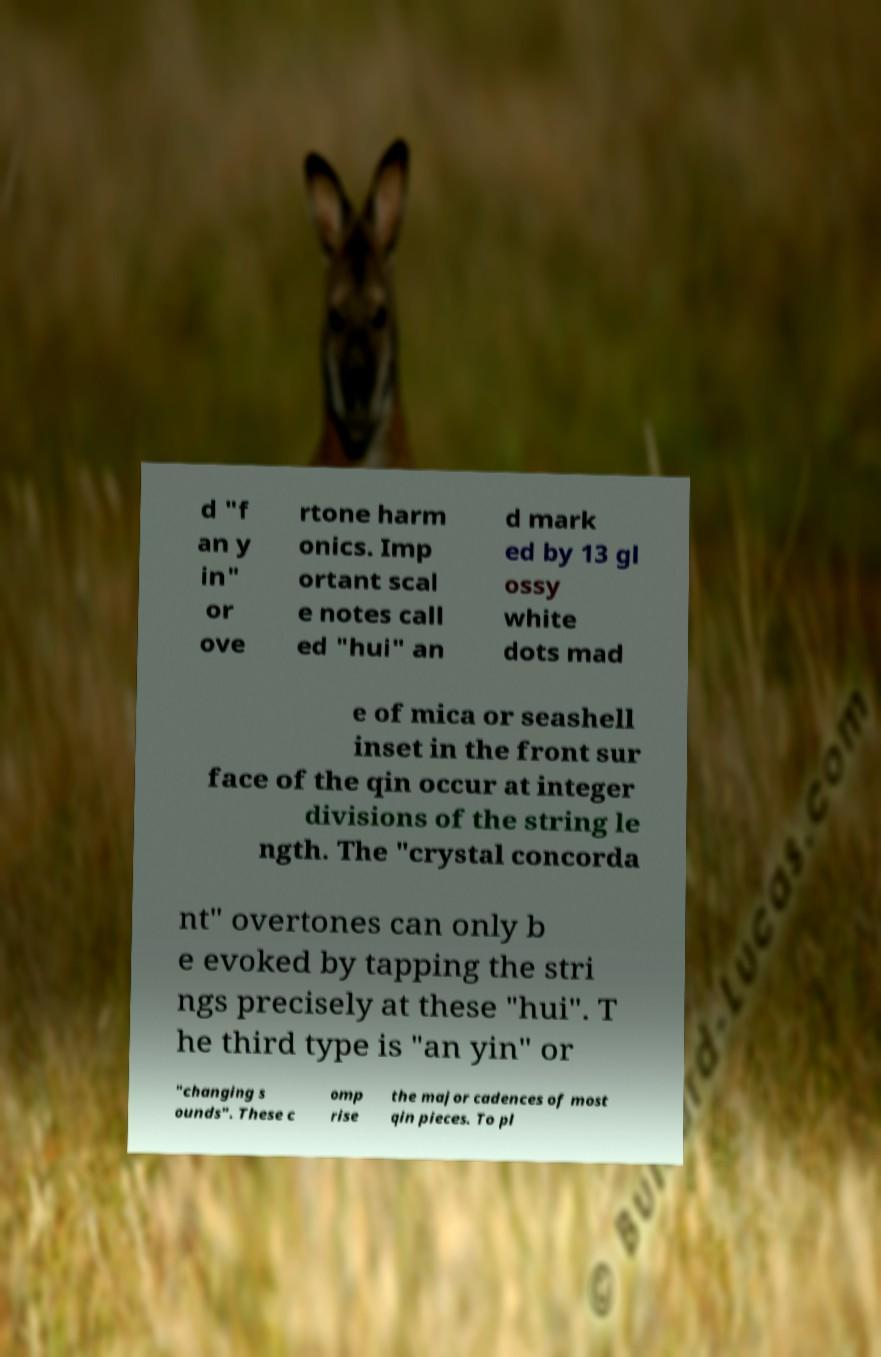Please identify and transcribe the text found in this image. d "f an y in" or ove rtone harm onics. Imp ortant scal e notes call ed "hui" an d mark ed by 13 gl ossy white dots mad e of mica or seashell inset in the front sur face of the qin occur at integer divisions of the string le ngth. The "crystal concorda nt" overtones can only b e evoked by tapping the stri ngs precisely at these "hui". T he third type is "an yin" or "changing s ounds". These c omp rise the major cadences of most qin pieces. To pl 